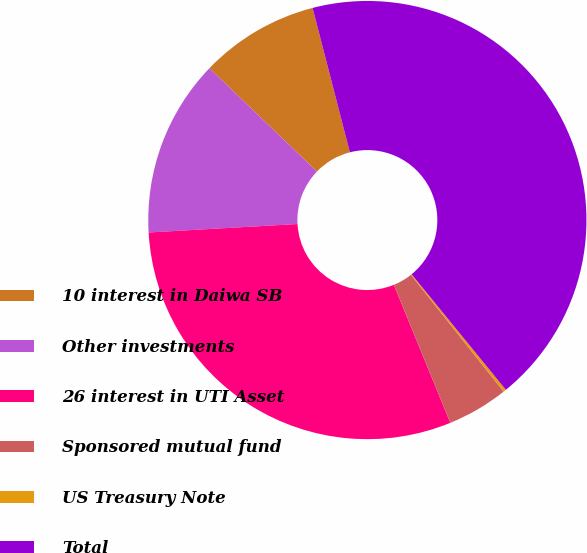<chart> <loc_0><loc_0><loc_500><loc_500><pie_chart><fcel>10 interest in Daiwa SB<fcel>Other investments<fcel>26 interest in UTI Asset<fcel>Sponsored mutual fund<fcel>US Treasury Note<fcel>Total<nl><fcel>8.79%<fcel>13.09%<fcel>30.28%<fcel>4.5%<fcel>0.21%<fcel>43.13%<nl></chart> 